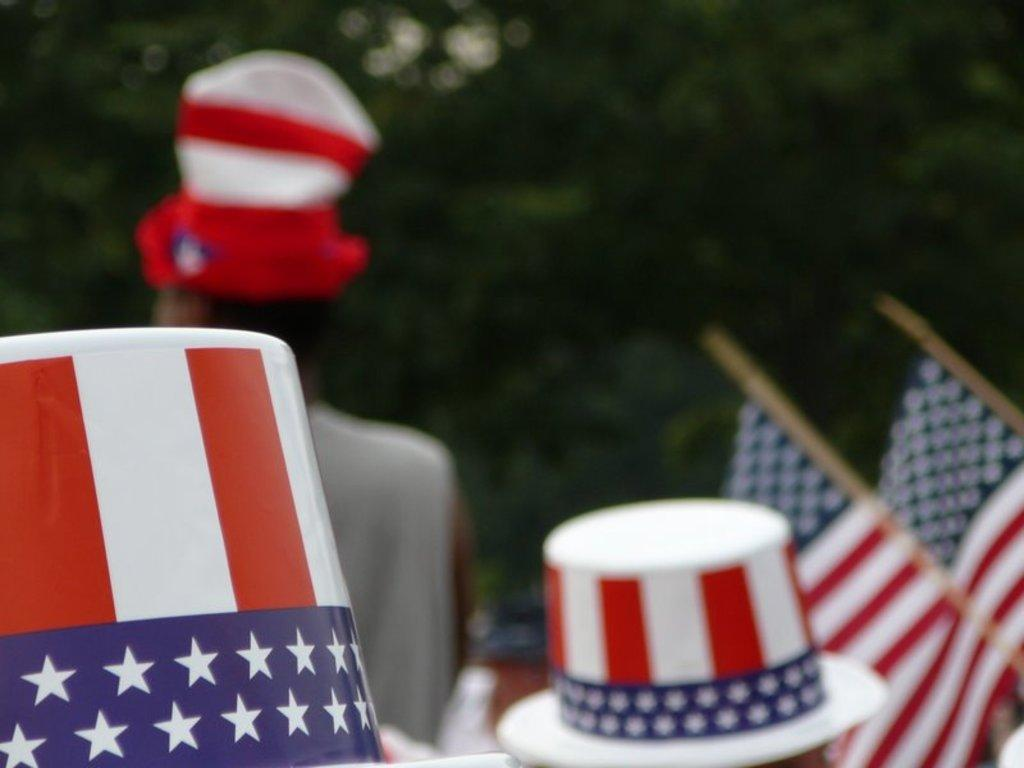How many caps can be seen in the image? There are two caps in the image. What is located on the right side of the image? There are two flags on the right side of the image. Can you describe the person in the image? There is a person in the image, but no specific details about their appearance or actions are provided. What can be seen in the background of the image? There are trees in the background of the image. What type of pleasure can be seen in the image? There is no indication of pleasure in the image; it features two caps, two flags, a person, and trees in the background. What is the plot of the story being depicted in the image? The image does not depict a story or plot; it is a static representation of the mentioned objects and person. 